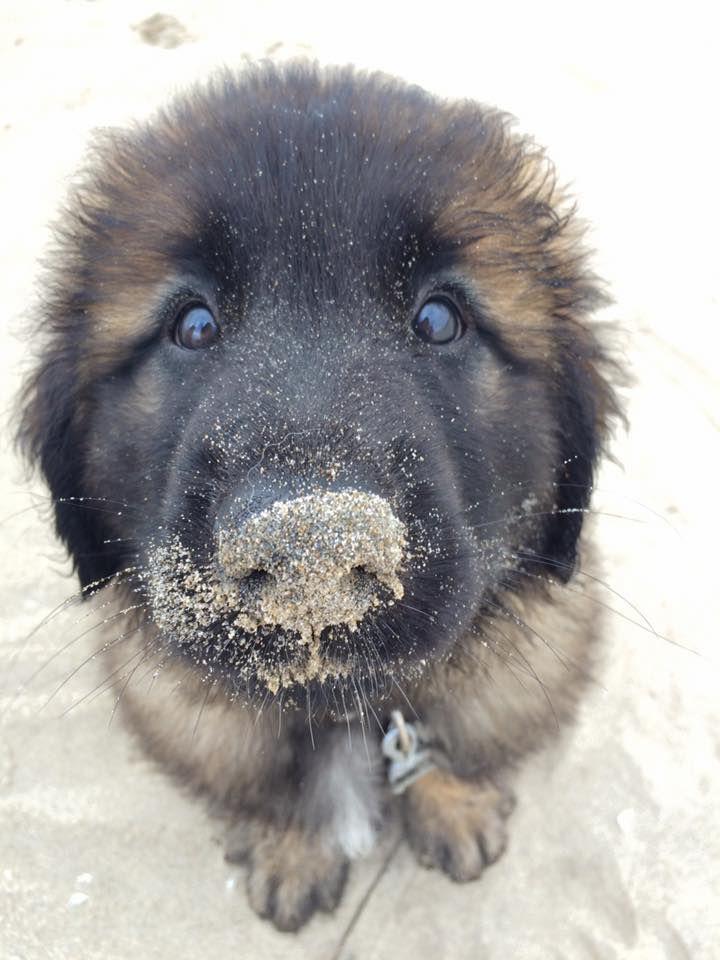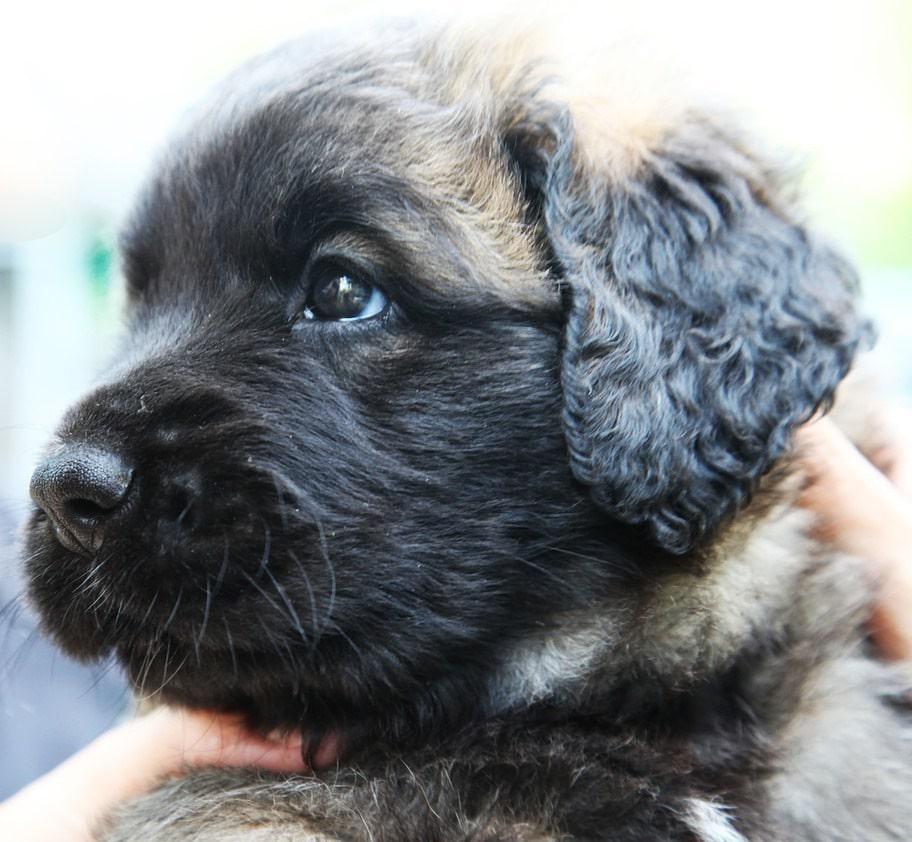The first image is the image on the left, the second image is the image on the right. Examine the images to the left and right. Is the description "A image shows one dog in a snowy outdoor setting." accurate? Answer yes or no. No. The first image is the image on the left, the second image is the image on the right. Examine the images to the left and right. Is the description "The dog in one of the images in on grass" accurate? Answer yes or no. No. 